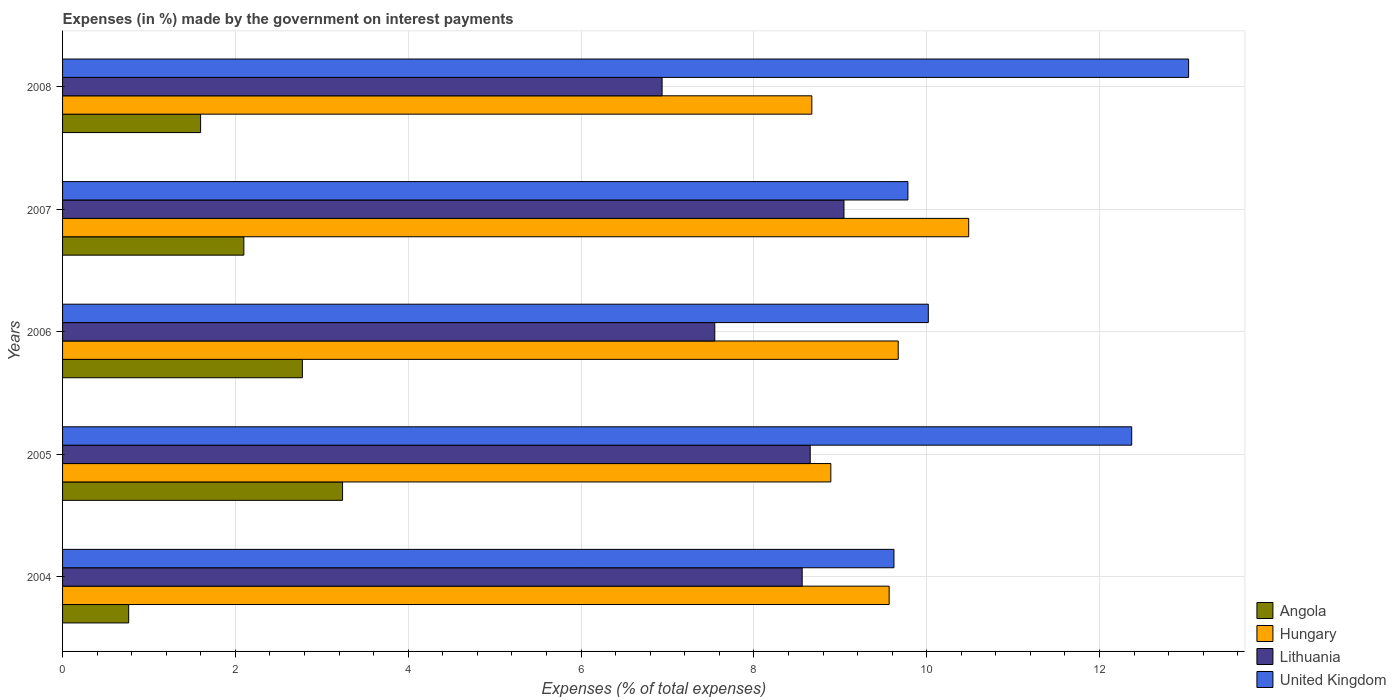How many groups of bars are there?
Provide a short and direct response. 5. Are the number of bars per tick equal to the number of legend labels?
Offer a very short reply. Yes. Are the number of bars on each tick of the Y-axis equal?
Your response must be concise. Yes. How many bars are there on the 2nd tick from the top?
Your answer should be very brief. 4. In how many cases, is the number of bars for a given year not equal to the number of legend labels?
Offer a terse response. 0. What is the percentage of expenses made by the government on interest payments in Angola in 2008?
Provide a succinct answer. 1.6. Across all years, what is the maximum percentage of expenses made by the government on interest payments in Hungary?
Provide a succinct answer. 10.49. Across all years, what is the minimum percentage of expenses made by the government on interest payments in Angola?
Make the answer very short. 0.76. In which year was the percentage of expenses made by the government on interest payments in United Kingdom minimum?
Keep it short and to the point. 2004. What is the total percentage of expenses made by the government on interest payments in Lithuania in the graph?
Your answer should be compact. 40.74. What is the difference between the percentage of expenses made by the government on interest payments in Lithuania in 2005 and that in 2007?
Offer a terse response. -0.39. What is the difference between the percentage of expenses made by the government on interest payments in United Kingdom in 2006 and the percentage of expenses made by the government on interest payments in Hungary in 2007?
Provide a short and direct response. -0.47. What is the average percentage of expenses made by the government on interest payments in Hungary per year?
Your answer should be very brief. 9.46. In the year 2005, what is the difference between the percentage of expenses made by the government on interest payments in Lithuania and percentage of expenses made by the government on interest payments in United Kingdom?
Offer a very short reply. -3.72. In how many years, is the percentage of expenses made by the government on interest payments in Hungary greater than 12.8 %?
Provide a succinct answer. 0. What is the ratio of the percentage of expenses made by the government on interest payments in United Kingdom in 2005 to that in 2007?
Your answer should be very brief. 1.26. Is the percentage of expenses made by the government on interest payments in Lithuania in 2006 less than that in 2008?
Your answer should be compact. No. Is the difference between the percentage of expenses made by the government on interest payments in Lithuania in 2004 and 2008 greater than the difference between the percentage of expenses made by the government on interest payments in United Kingdom in 2004 and 2008?
Provide a short and direct response. Yes. What is the difference between the highest and the second highest percentage of expenses made by the government on interest payments in Lithuania?
Your response must be concise. 0.39. What is the difference between the highest and the lowest percentage of expenses made by the government on interest payments in Hungary?
Provide a short and direct response. 1.82. In how many years, is the percentage of expenses made by the government on interest payments in United Kingdom greater than the average percentage of expenses made by the government on interest payments in United Kingdom taken over all years?
Keep it short and to the point. 2. Is the sum of the percentage of expenses made by the government on interest payments in Hungary in 2005 and 2008 greater than the maximum percentage of expenses made by the government on interest payments in United Kingdom across all years?
Your response must be concise. Yes. What does the 4th bar from the top in 2006 represents?
Keep it short and to the point. Angola. What does the 2nd bar from the bottom in 2007 represents?
Keep it short and to the point. Hungary. Is it the case that in every year, the sum of the percentage of expenses made by the government on interest payments in Hungary and percentage of expenses made by the government on interest payments in Lithuania is greater than the percentage of expenses made by the government on interest payments in Angola?
Offer a very short reply. Yes. How many bars are there?
Your answer should be compact. 20. How many years are there in the graph?
Provide a short and direct response. 5. Are the values on the major ticks of X-axis written in scientific E-notation?
Your answer should be very brief. No. Where does the legend appear in the graph?
Your answer should be very brief. Bottom right. How many legend labels are there?
Make the answer very short. 4. How are the legend labels stacked?
Your response must be concise. Vertical. What is the title of the graph?
Keep it short and to the point. Expenses (in %) made by the government on interest payments. What is the label or title of the X-axis?
Offer a very short reply. Expenses (% of total expenses). What is the Expenses (% of total expenses) of Angola in 2004?
Your response must be concise. 0.76. What is the Expenses (% of total expenses) in Hungary in 2004?
Provide a succinct answer. 9.57. What is the Expenses (% of total expenses) of Lithuania in 2004?
Offer a very short reply. 8.56. What is the Expenses (% of total expenses) in United Kingdom in 2004?
Make the answer very short. 9.62. What is the Expenses (% of total expenses) of Angola in 2005?
Offer a very short reply. 3.24. What is the Expenses (% of total expenses) of Hungary in 2005?
Provide a succinct answer. 8.89. What is the Expenses (% of total expenses) in Lithuania in 2005?
Offer a very short reply. 8.65. What is the Expenses (% of total expenses) in United Kingdom in 2005?
Your answer should be very brief. 12.37. What is the Expenses (% of total expenses) in Angola in 2006?
Offer a very short reply. 2.78. What is the Expenses (% of total expenses) of Hungary in 2006?
Ensure brevity in your answer.  9.67. What is the Expenses (% of total expenses) of Lithuania in 2006?
Offer a very short reply. 7.55. What is the Expenses (% of total expenses) in United Kingdom in 2006?
Keep it short and to the point. 10.02. What is the Expenses (% of total expenses) in Angola in 2007?
Provide a short and direct response. 2.1. What is the Expenses (% of total expenses) in Hungary in 2007?
Keep it short and to the point. 10.49. What is the Expenses (% of total expenses) of Lithuania in 2007?
Provide a succinct answer. 9.04. What is the Expenses (% of total expenses) of United Kingdom in 2007?
Make the answer very short. 9.78. What is the Expenses (% of total expenses) in Angola in 2008?
Offer a terse response. 1.6. What is the Expenses (% of total expenses) in Hungary in 2008?
Give a very brief answer. 8.67. What is the Expenses (% of total expenses) in Lithuania in 2008?
Provide a short and direct response. 6.94. What is the Expenses (% of total expenses) of United Kingdom in 2008?
Offer a terse response. 13.03. Across all years, what is the maximum Expenses (% of total expenses) of Angola?
Keep it short and to the point. 3.24. Across all years, what is the maximum Expenses (% of total expenses) in Hungary?
Your answer should be compact. 10.49. Across all years, what is the maximum Expenses (% of total expenses) in Lithuania?
Keep it short and to the point. 9.04. Across all years, what is the maximum Expenses (% of total expenses) in United Kingdom?
Keep it short and to the point. 13.03. Across all years, what is the minimum Expenses (% of total expenses) of Angola?
Provide a short and direct response. 0.76. Across all years, what is the minimum Expenses (% of total expenses) of Hungary?
Your response must be concise. 8.67. Across all years, what is the minimum Expenses (% of total expenses) of Lithuania?
Ensure brevity in your answer.  6.94. Across all years, what is the minimum Expenses (% of total expenses) in United Kingdom?
Keep it short and to the point. 9.62. What is the total Expenses (% of total expenses) of Angola in the graph?
Offer a terse response. 10.48. What is the total Expenses (% of total expenses) in Hungary in the graph?
Ensure brevity in your answer.  47.28. What is the total Expenses (% of total expenses) in Lithuania in the graph?
Your response must be concise. 40.74. What is the total Expenses (% of total expenses) of United Kingdom in the graph?
Your response must be concise. 54.83. What is the difference between the Expenses (% of total expenses) in Angola in 2004 and that in 2005?
Offer a very short reply. -2.48. What is the difference between the Expenses (% of total expenses) of Hungary in 2004 and that in 2005?
Offer a very short reply. 0.68. What is the difference between the Expenses (% of total expenses) of Lithuania in 2004 and that in 2005?
Provide a succinct answer. -0.09. What is the difference between the Expenses (% of total expenses) in United Kingdom in 2004 and that in 2005?
Provide a succinct answer. -2.75. What is the difference between the Expenses (% of total expenses) of Angola in 2004 and that in 2006?
Offer a terse response. -2.01. What is the difference between the Expenses (% of total expenses) of Hungary in 2004 and that in 2006?
Your response must be concise. -0.1. What is the difference between the Expenses (% of total expenses) in Lithuania in 2004 and that in 2006?
Offer a very short reply. 1.01. What is the difference between the Expenses (% of total expenses) of United Kingdom in 2004 and that in 2006?
Provide a short and direct response. -0.4. What is the difference between the Expenses (% of total expenses) of Angola in 2004 and that in 2007?
Provide a succinct answer. -1.33. What is the difference between the Expenses (% of total expenses) of Hungary in 2004 and that in 2007?
Your response must be concise. -0.92. What is the difference between the Expenses (% of total expenses) in Lithuania in 2004 and that in 2007?
Keep it short and to the point. -0.48. What is the difference between the Expenses (% of total expenses) in United Kingdom in 2004 and that in 2007?
Provide a short and direct response. -0.16. What is the difference between the Expenses (% of total expenses) of Angola in 2004 and that in 2008?
Make the answer very short. -0.83. What is the difference between the Expenses (% of total expenses) in Hungary in 2004 and that in 2008?
Provide a succinct answer. 0.89. What is the difference between the Expenses (% of total expenses) of Lithuania in 2004 and that in 2008?
Make the answer very short. 1.62. What is the difference between the Expenses (% of total expenses) in United Kingdom in 2004 and that in 2008?
Provide a short and direct response. -3.41. What is the difference between the Expenses (% of total expenses) in Angola in 2005 and that in 2006?
Your response must be concise. 0.46. What is the difference between the Expenses (% of total expenses) in Hungary in 2005 and that in 2006?
Ensure brevity in your answer.  -0.78. What is the difference between the Expenses (% of total expenses) in Lithuania in 2005 and that in 2006?
Give a very brief answer. 1.1. What is the difference between the Expenses (% of total expenses) in United Kingdom in 2005 and that in 2006?
Offer a terse response. 2.35. What is the difference between the Expenses (% of total expenses) in Angola in 2005 and that in 2007?
Your response must be concise. 1.14. What is the difference between the Expenses (% of total expenses) in Hungary in 2005 and that in 2007?
Offer a terse response. -1.6. What is the difference between the Expenses (% of total expenses) in Lithuania in 2005 and that in 2007?
Give a very brief answer. -0.39. What is the difference between the Expenses (% of total expenses) in United Kingdom in 2005 and that in 2007?
Your answer should be very brief. 2.59. What is the difference between the Expenses (% of total expenses) of Angola in 2005 and that in 2008?
Your answer should be compact. 1.64. What is the difference between the Expenses (% of total expenses) in Hungary in 2005 and that in 2008?
Keep it short and to the point. 0.22. What is the difference between the Expenses (% of total expenses) in Lithuania in 2005 and that in 2008?
Provide a succinct answer. 1.71. What is the difference between the Expenses (% of total expenses) in United Kingdom in 2005 and that in 2008?
Make the answer very short. -0.66. What is the difference between the Expenses (% of total expenses) in Angola in 2006 and that in 2007?
Give a very brief answer. 0.68. What is the difference between the Expenses (% of total expenses) in Hungary in 2006 and that in 2007?
Give a very brief answer. -0.82. What is the difference between the Expenses (% of total expenses) of Lithuania in 2006 and that in 2007?
Offer a terse response. -1.5. What is the difference between the Expenses (% of total expenses) of United Kingdom in 2006 and that in 2007?
Offer a very short reply. 0.24. What is the difference between the Expenses (% of total expenses) of Angola in 2006 and that in 2008?
Offer a very short reply. 1.18. What is the difference between the Expenses (% of total expenses) of Hungary in 2006 and that in 2008?
Ensure brevity in your answer.  1. What is the difference between the Expenses (% of total expenses) in Lithuania in 2006 and that in 2008?
Provide a succinct answer. 0.61. What is the difference between the Expenses (% of total expenses) of United Kingdom in 2006 and that in 2008?
Provide a short and direct response. -3.01. What is the difference between the Expenses (% of total expenses) of Angola in 2007 and that in 2008?
Offer a very short reply. 0.5. What is the difference between the Expenses (% of total expenses) of Hungary in 2007 and that in 2008?
Provide a short and direct response. 1.82. What is the difference between the Expenses (% of total expenses) of Lithuania in 2007 and that in 2008?
Your response must be concise. 2.1. What is the difference between the Expenses (% of total expenses) of United Kingdom in 2007 and that in 2008?
Make the answer very short. -3.25. What is the difference between the Expenses (% of total expenses) in Angola in 2004 and the Expenses (% of total expenses) in Hungary in 2005?
Offer a terse response. -8.13. What is the difference between the Expenses (% of total expenses) of Angola in 2004 and the Expenses (% of total expenses) of Lithuania in 2005?
Keep it short and to the point. -7.89. What is the difference between the Expenses (% of total expenses) of Angola in 2004 and the Expenses (% of total expenses) of United Kingdom in 2005?
Offer a very short reply. -11.61. What is the difference between the Expenses (% of total expenses) in Hungary in 2004 and the Expenses (% of total expenses) in Lithuania in 2005?
Your answer should be very brief. 0.91. What is the difference between the Expenses (% of total expenses) of Hungary in 2004 and the Expenses (% of total expenses) of United Kingdom in 2005?
Offer a very short reply. -2.81. What is the difference between the Expenses (% of total expenses) of Lithuania in 2004 and the Expenses (% of total expenses) of United Kingdom in 2005?
Provide a short and direct response. -3.81. What is the difference between the Expenses (% of total expenses) in Angola in 2004 and the Expenses (% of total expenses) in Hungary in 2006?
Offer a terse response. -8.91. What is the difference between the Expenses (% of total expenses) in Angola in 2004 and the Expenses (% of total expenses) in Lithuania in 2006?
Your answer should be very brief. -6.78. What is the difference between the Expenses (% of total expenses) of Angola in 2004 and the Expenses (% of total expenses) of United Kingdom in 2006?
Provide a succinct answer. -9.25. What is the difference between the Expenses (% of total expenses) of Hungary in 2004 and the Expenses (% of total expenses) of Lithuania in 2006?
Offer a very short reply. 2.02. What is the difference between the Expenses (% of total expenses) in Hungary in 2004 and the Expenses (% of total expenses) in United Kingdom in 2006?
Give a very brief answer. -0.45. What is the difference between the Expenses (% of total expenses) of Lithuania in 2004 and the Expenses (% of total expenses) of United Kingdom in 2006?
Offer a very short reply. -1.46. What is the difference between the Expenses (% of total expenses) of Angola in 2004 and the Expenses (% of total expenses) of Hungary in 2007?
Offer a terse response. -9.72. What is the difference between the Expenses (% of total expenses) in Angola in 2004 and the Expenses (% of total expenses) in Lithuania in 2007?
Provide a short and direct response. -8.28. What is the difference between the Expenses (% of total expenses) in Angola in 2004 and the Expenses (% of total expenses) in United Kingdom in 2007?
Make the answer very short. -9.02. What is the difference between the Expenses (% of total expenses) in Hungary in 2004 and the Expenses (% of total expenses) in Lithuania in 2007?
Offer a terse response. 0.52. What is the difference between the Expenses (% of total expenses) in Hungary in 2004 and the Expenses (% of total expenses) in United Kingdom in 2007?
Offer a terse response. -0.22. What is the difference between the Expenses (% of total expenses) in Lithuania in 2004 and the Expenses (% of total expenses) in United Kingdom in 2007?
Keep it short and to the point. -1.22. What is the difference between the Expenses (% of total expenses) of Angola in 2004 and the Expenses (% of total expenses) of Hungary in 2008?
Your answer should be very brief. -7.91. What is the difference between the Expenses (% of total expenses) of Angola in 2004 and the Expenses (% of total expenses) of Lithuania in 2008?
Keep it short and to the point. -6.17. What is the difference between the Expenses (% of total expenses) in Angola in 2004 and the Expenses (% of total expenses) in United Kingdom in 2008?
Ensure brevity in your answer.  -12.27. What is the difference between the Expenses (% of total expenses) of Hungary in 2004 and the Expenses (% of total expenses) of Lithuania in 2008?
Ensure brevity in your answer.  2.63. What is the difference between the Expenses (% of total expenses) of Hungary in 2004 and the Expenses (% of total expenses) of United Kingdom in 2008?
Ensure brevity in your answer.  -3.47. What is the difference between the Expenses (% of total expenses) in Lithuania in 2004 and the Expenses (% of total expenses) in United Kingdom in 2008?
Provide a succinct answer. -4.47. What is the difference between the Expenses (% of total expenses) in Angola in 2005 and the Expenses (% of total expenses) in Hungary in 2006?
Provide a short and direct response. -6.43. What is the difference between the Expenses (% of total expenses) in Angola in 2005 and the Expenses (% of total expenses) in Lithuania in 2006?
Provide a short and direct response. -4.31. What is the difference between the Expenses (% of total expenses) of Angola in 2005 and the Expenses (% of total expenses) of United Kingdom in 2006?
Offer a very short reply. -6.78. What is the difference between the Expenses (% of total expenses) of Hungary in 2005 and the Expenses (% of total expenses) of Lithuania in 2006?
Your answer should be compact. 1.34. What is the difference between the Expenses (% of total expenses) of Hungary in 2005 and the Expenses (% of total expenses) of United Kingdom in 2006?
Your answer should be very brief. -1.13. What is the difference between the Expenses (% of total expenses) of Lithuania in 2005 and the Expenses (% of total expenses) of United Kingdom in 2006?
Your answer should be very brief. -1.37. What is the difference between the Expenses (% of total expenses) in Angola in 2005 and the Expenses (% of total expenses) in Hungary in 2007?
Make the answer very short. -7.25. What is the difference between the Expenses (% of total expenses) of Angola in 2005 and the Expenses (% of total expenses) of Lithuania in 2007?
Offer a very short reply. -5.8. What is the difference between the Expenses (% of total expenses) of Angola in 2005 and the Expenses (% of total expenses) of United Kingdom in 2007?
Keep it short and to the point. -6.54. What is the difference between the Expenses (% of total expenses) in Hungary in 2005 and the Expenses (% of total expenses) in Lithuania in 2007?
Provide a short and direct response. -0.15. What is the difference between the Expenses (% of total expenses) in Hungary in 2005 and the Expenses (% of total expenses) in United Kingdom in 2007?
Make the answer very short. -0.89. What is the difference between the Expenses (% of total expenses) in Lithuania in 2005 and the Expenses (% of total expenses) in United Kingdom in 2007?
Your answer should be compact. -1.13. What is the difference between the Expenses (% of total expenses) in Angola in 2005 and the Expenses (% of total expenses) in Hungary in 2008?
Provide a succinct answer. -5.43. What is the difference between the Expenses (% of total expenses) of Angola in 2005 and the Expenses (% of total expenses) of Lithuania in 2008?
Ensure brevity in your answer.  -3.7. What is the difference between the Expenses (% of total expenses) of Angola in 2005 and the Expenses (% of total expenses) of United Kingdom in 2008?
Keep it short and to the point. -9.79. What is the difference between the Expenses (% of total expenses) in Hungary in 2005 and the Expenses (% of total expenses) in Lithuania in 2008?
Your answer should be compact. 1.95. What is the difference between the Expenses (% of total expenses) in Hungary in 2005 and the Expenses (% of total expenses) in United Kingdom in 2008?
Ensure brevity in your answer.  -4.14. What is the difference between the Expenses (% of total expenses) in Lithuania in 2005 and the Expenses (% of total expenses) in United Kingdom in 2008?
Your answer should be compact. -4.38. What is the difference between the Expenses (% of total expenses) in Angola in 2006 and the Expenses (% of total expenses) in Hungary in 2007?
Your response must be concise. -7.71. What is the difference between the Expenses (% of total expenses) in Angola in 2006 and the Expenses (% of total expenses) in Lithuania in 2007?
Offer a very short reply. -6.27. What is the difference between the Expenses (% of total expenses) in Angola in 2006 and the Expenses (% of total expenses) in United Kingdom in 2007?
Ensure brevity in your answer.  -7.01. What is the difference between the Expenses (% of total expenses) of Hungary in 2006 and the Expenses (% of total expenses) of Lithuania in 2007?
Give a very brief answer. 0.63. What is the difference between the Expenses (% of total expenses) in Hungary in 2006 and the Expenses (% of total expenses) in United Kingdom in 2007?
Offer a very short reply. -0.11. What is the difference between the Expenses (% of total expenses) in Lithuania in 2006 and the Expenses (% of total expenses) in United Kingdom in 2007?
Provide a short and direct response. -2.23. What is the difference between the Expenses (% of total expenses) in Angola in 2006 and the Expenses (% of total expenses) in Hungary in 2008?
Your answer should be compact. -5.9. What is the difference between the Expenses (% of total expenses) in Angola in 2006 and the Expenses (% of total expenses) in Lithuania in 2008?
Give a very brief answer. -4.16. What is the difference between the Expenses (% of total expenses) of Angola in 2006 and the Expenses (% of total expenses) of United Kingdom in 2008?
Ensure brevity in your answer.  -10.26. What is the difference between the Expenses (% of total expenses) in Hungary in 2006 and the Expenses (% of total expenses) in Lithuania in 2008?
Offer a very short reply. 2.73. What is the difference between the Expenses (% of total expenses) in Hungary in 2006 and the Expenses (% of total expenses) in United Kingdom in 2008?
Keep it short and to the point. -3.36. What is the difference between the Expenses (% of total expenses) of Lithuania in 2006 and the Expenses (% of total expenses) of United Kingdom in 2008?
Offer a terse response. -5.48. What is the difference between the Expenses (% of total expenses) of Angola in 2007 and the Expenses (% of total expenses) of Hungary in 2008?
Your response must be concise. -6.57. What is the difference between the Expenses (% of total expenses) in Angola in 2007 and the Expenses (% of total expenses) in Lithuania in 2008?
Your response must be concise. -4.84. What is the difference between the Expenses (% of total expenses) of Angola in 2007 and the Expenses (% of total expenses) of United Kingdom in 2008?
Offer a terse response. -10.93. What is the difference between the Expenses (% of total expenses) in Hungary in 2007 and the Expenses (% of total expenses) in Lithuania in 2008?
Your answer should be compact. 3.55. What is the difference between the Expenses (% of total expenses) in Hungary in 2007 and the Expenses (% of total expenses) in United Kingdom in 2008?
Ensure brevity in your answer.  -2.54. What is the difference between the Expenses (% of total expenses) in Lithuania in 2007 and the Expenses (% of total expenses) in United Kingdom in 2008?
Offer a very short reply. -3.99. What is the average Expenses (% of total expenses) of Angola per year?
Make the answer very short. 2.1. What is the average Expenses (% of total expenses) of Hungary per year?
Offer a very short reply. 9.46. What is the average Expenses (% of total expenses) in Lithuania per year?
Your answer should be compact. 8.15. What is the average Expenses (% of total expenses) of United Kingdom per year?
Provide a short and direct response. 10.97. In the year 2004, what is the difference between the Expenses (% of total expenses) of Angola and Expenses (% of total expenses) of Hungary?
Offer a terse response. -8.8. In the year 2004, what is the difference between the Expenses (% of total expenses) of Angola and Expenses (% of total expenses) of Lithuania?
Offer a very short reply. -7.79. In the year 2004, what is the difference between the Expenses (% of total expenses) in Angola and Expenses (% of total expenses) in United Kingdom?
Make the answer very short. -8.86. In the year 2004, what is the difference between the Expenses (% of total expenses) of Hungary and Expenses (% of total expenses) of Lithuania?
Make the answer very short. 1.01. In the year 2004, what is the difference between the Expenses (% of total expenses) in Hungary and Expenses (% of total expenses) in United Kingdom?
Give a very brief answer. -0.06. In the year 2004, what is the difference between the Expenses (% of total expenses) of Lithuania and Expenses (% of total expenses) of United Kingdom?
Your answer should be compact. -1.06. In the year 2005, what is the difference between the Expenses (% of total expenses) in Angola and Expenses (% of total expenses) in Hungary?
Offer a very short reply. -5.65. In the year 2005, what is the difference between the Expenses (% of total expenses) of Angola and Expenses (% of total expenses) of Lithuania?
Offer a terse response. -5.41. In the year 2005, what is the difference between the Expenses (% of total expenses) of Angola and Expenses (% of total expenses) of United Kingdom?
Provide a short and direct response. -9.13. In the year 2005, what is the difference between the Expenses (% of total expenses) in Hungary and Expenses (% of total expenses) in Lithuania?
Provide a short and direct response. 0.24. In the year 2005, what is the difference between the Expenses (% of total expenses) in Hungary and Expenses (% of total expenses) in United Kingdom?
Offer a very short reply. -3.48. In the year 2005, what is the difference between the Expenses (% of total expenses) in Lithuania and Expenses (% of total expenses) in United Kingdom?
Your response must be concise. -3.72. In the year 2006, what is the difference between the Expenses (% of total expenses) of Angola and Expenses (% of total expenses) of Hungary?
Your response must be concise. -6.89. In the year 2006, what is the difference between the Expenses (% of total expenses) of Angola and Expenses (% of total expenses) of Lithuania?
Provide a succinct answer. -4.77. In the year 2006, what is the difference between the Expenses (% of total expenses) of Angola and Expenses (% of total expenses) of United Kingdom?
Provide a succinct answer. -7.24. In the year 2006, what is the difference between the Expenses (% of total expenses) of Hungary and Expenses (% of total expenses) of Lithuania?
Offer a very short reply. 2.12. In the year 2006, what is the difference between the Expenses (% of total expenses) in Hungary and Expenses (% of total expenses) in United Kingdom?
Your response must be concise. -0.35. In the year 2006, what is the difference between the Expenses (% of total expenses) of Lithuania and Expenses (% of total expenses) of United Kingdom?
Ensure brevity in your answer.  -2.47. In the year 2007, what is the difference between the Expenses (% of total expenses) in Angola and Expenses (% of total expenses) in Hungary?
Your answer should be compact. -8.39. In the year 2007, what is the difference between the Expenses (% of total expenses) of Angola and Expenses (% of total expenses) of Lithuania?
Keep it short and to the point. -6.94. In the year 2007, what is the difference between the Expenses (% of total expenses) in Angola and Expenses (% of total expenses) in United Kingdom?
Offer a very short reply. -7.68. In the year 2007, what is the difference between the Expenses (% of total expenses) of Hungary and Expenses (% of total expenses) of Lithuania?
Keep it short and to the point. 1.44. In the year 2007, what is the difference between the Expenses (% of total expenses) in Hungary and Expenses (% of total expenses) in United Kingdom?
Offer a very short reply. 0.7. In the year 2007, what is the difference between the Expenses (% of total expenses) in Lithuania and Expenses (% of total expenses) in United Kingdom?
Provide a short and direct response. -0.74. In the year 2008, what is the difference between the Expenses (% of total expenses) in Angola and Expenses (% of total expenses) in Hungary?
Offer a terse response. -7.07. In the year 2008, what is the difference between the Expenses (% of total expenses) in Angola and Expenses (% of total expenses) in Lithuania?
Keep it short and to the point. -5.34. In the year 2008, what is the difference between the Expenses (% of total expenses) in Angola and Expenses (% of total expenses) in United Kingdom?
Keep it short and to the point. -11.43. In the year 2008, what is the difference between the Expenses (% of total expenses) in Hungary and Expenses (% of total expenses) in Lithuania?
Your answer should be very brief. 1.73. In the year 2008, what is the difference between the Expenses (% of total expenses) in Hungary and Expenses (% of total expenses) in United Kingdom?
Your answer should be compact. -4.36. In the year 2008, what is the difference between the Expenses (% of total expenses) in Lithuania and Expenses (% of total expenses) in United Kingdom?
Your response must be concise. -6.09. What is the ratio of the Expenses (% of total expenses) of Angola in 2004 to that in 2005?
Your answer should be very brief. 0.24. What is the ratio of the Expenses (% of total expenses) of Hungary in 2004 to that in 2005?
Provide a short and direct response. 1.08. What is the ratio of the Expenses (% of total expenses) of United Kingdom in 2004 to that in 2005?
Give a very brief answer. 0.78. What is the ratio of the Expenses (% of total expenses) in Angola in 2004 to that in 2006?
Your response must be concise. 0.28. What is the ratio of the Expenses (% of total expenses) in Lithuania in 2004 to that in 2006?
Offer a terse response. 1.13. What is the ratio of the Expenses (% of total expenses) in United Kingdom in 2004 to that in 2006?
Provide a succinct answer. 0.96. What is the ratio of the Expenses (% of total expenses) of Angola in 2004 to that in 2007?
Your response must be concise. 0.36. What is the ratio of the Expenses (% of total expenses) of Hungary in 2004 to that in 2007?
Provide a succinct answer. 0.91. What is the ratio of the Expenses (% of total expenses) of Lithuania in 2004 to that in 2007?
Your answer should be very brief. 0.95. What is the ratio of the Expenses (% of total expenses) of United Kingdom in 2004 to that in 2007?
Provide a succinct answer. 0.98. What is the ratio of the Expenses (% of total expenses) of Angola in 2004 to that in 2008?
Your answer should be compact. 0.48. What is the ratio of the Expenses (% of total expenses) in Hungary in 2004 to that in 2008?
Give a very brief answer. 1.1. What is the ratio of the Expenses (% of total expenses) in Lithuania in 2004 to that in 2008?
Make the answer very short. 1.23. What is the ratio of the Expenses (% of total expenses) of United Kingdom in 2004 to that in 2008?
Your response must be concise. 0.74. What is the ratio of the Expenses (% of total expenses) of Angola in 2005 to that in 2006?
Your answer should be compact. 1.17. What is the ratio of the Expenses (% of total expenses) of Hungary in 2005 to that in 2006?
Ensure brevity in your answer.  0.92. What is the ratio of the Expenses (% of total expenses) in Lithuania in 2005 to that in 2006?
Make the answer very short. 1.15. What is the ratio of the Expenses (% of total expenses) in United Kingdom in 2005 to that in 2006?
Your answer should be very brief. 1.23. What is the ratio of the Expenses (% of total expenses) of Angola in 2005 to that in 2007?
Provide a short and direct response. 1.54. What is the ratio of the Expenses (% of total expenses) of Hungary in 2005 to that in 2007?
Provide a short and direct response. 0.85. What is the ratio of the Expenses (% of total expenses) in Lithuania in 2005 to that in 2007?
Your answer should be compact. 0.96. What is the ratio of the Expenses (% of total expenses) in United Kingdom in 2005 to that in 2007?
Give a very brief answer. 1.26. What is the ratio of the Expenses (% of total expenses) of Angola in 2005 to that in 2008?
Your answer should be compact. 2.03. What is the ratio of the Expenses (% of total expenses) of Hungary in 2005 to that in 2008?
Offer a terse response. 1.03. What is the ratio of the Expenses (% of total expenses) in Lithuania in 2005 to that in 2008?
Ensure brevity in your answer.  1.25. What is the ratio of the Expenses (% of total expenses) in United Kingdom in 2005 to that in 2008?
Offer a very short reply. 0.95. What is the ratio of the Expenses (% of total expenses) in Angola in 2006 to that in 2007?
Make the answer very short. 1.32. What is the ratio of the Expenses (% of total expenses) of Hungary in 2006 to that in 2007?
Provide a succinct answer. 0.92. What is the ratio of the Expenses (% of total expenses) of Lithuania in 2006 to that in 2007?
Ensure brevity in your answer.  0.83. What is the ratio of the Expenses (% of total expenses) of United Kingdom in 2006 to that in 2007?
Offer a terse response. 1.02. What is the ratio of the Expenses (% of total expenses) in Angola in 2006 to that in 2008?
Offer a terse response. 1.74. What is the ratio of the Expenses (% of total expenses) of Hungary in 2006 to that in 2008?
Your answer should be compact. 1.12. What is the ratio of the Expenses (% of total expenses) in Lithuania in 2006 to that in 2008?
Give a very brief answer. 1.09. What is the ratio of the Expenses (% of total expenses) in United Kingdom in 2006 to that in 2008?
Ensure brevity in your answer.  0.77. What is the ratio of the Expenses (% of total expenses) of Angola in 2007 to that in 2008?
Give a very brief answer. 1.31. What is the ratio of the Expenses (% of total expenses) in Hungary in 2007 to that in 2008?
Keep it short and to the point. 1.21. What is the ratio of the Expenses (% of total expenses) in Lithuania in 2007 to that in 2008?
Your response must be concise. 1.3. What is the ratio of the Expenses (% of total expenses) in United Kingdom in 2007 to that in 2008?
Keep it short and to the point. 0.75. What is the difference between the highest and the second highest Expenses (% of total expenses) of Angola?
Offer a terse response. 0.46. What is the difference between the highest and the second highest Expenses (% of total expenses) in Hungary?
Keep it short and to the point. 0.82. What is the difference between the highest and the second highest Expenses (% of total expenses) in Lithuania?
Provide a short and direct response. 0.39. What is the difference between the highest and the second highest Expenses (% of total expenses) in United Kingdom?
Make the answer very short. 0.66. What is the difference between the highest and the lowest Expenses (% of total expenses) in Angola?
Your answer should be very brief. 2.48. What is the difference between the highest and the lowest Expenses (% of total expenses) in Hungary?
Provide a short and direct response. 1.82. What is the difference between the highest and the lowest Expenses (% of total expenses) in Lithuania?
Your response must be concise. 2.1. What is the difference between the highest and the lowest Expenses (% of total expenses) of United Kingdom?
Provide a succinct answer. 3.41. 